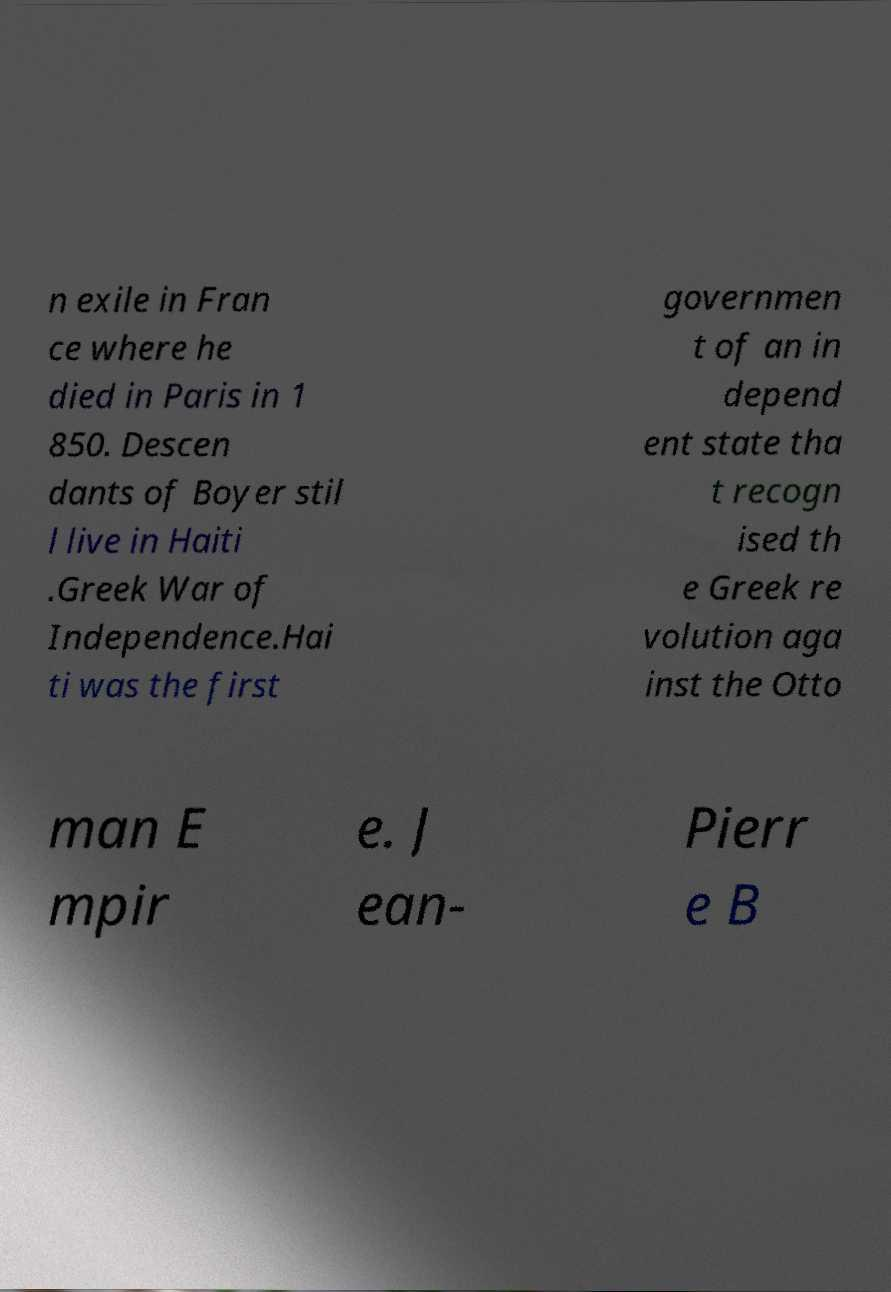What messages or text are displayed in this image? I need them in a readable, typed format. n exile in Fran ce where he died in Paris in 1 850. Descen dants of Boyer stil l live in Haiti .Greek War of Independence.Hai ti was the first governmen t of an in depend ent state tha t recogn ised th e Greek re volution aga inst the Otto man E mpir e. J ean- Pierr e B 